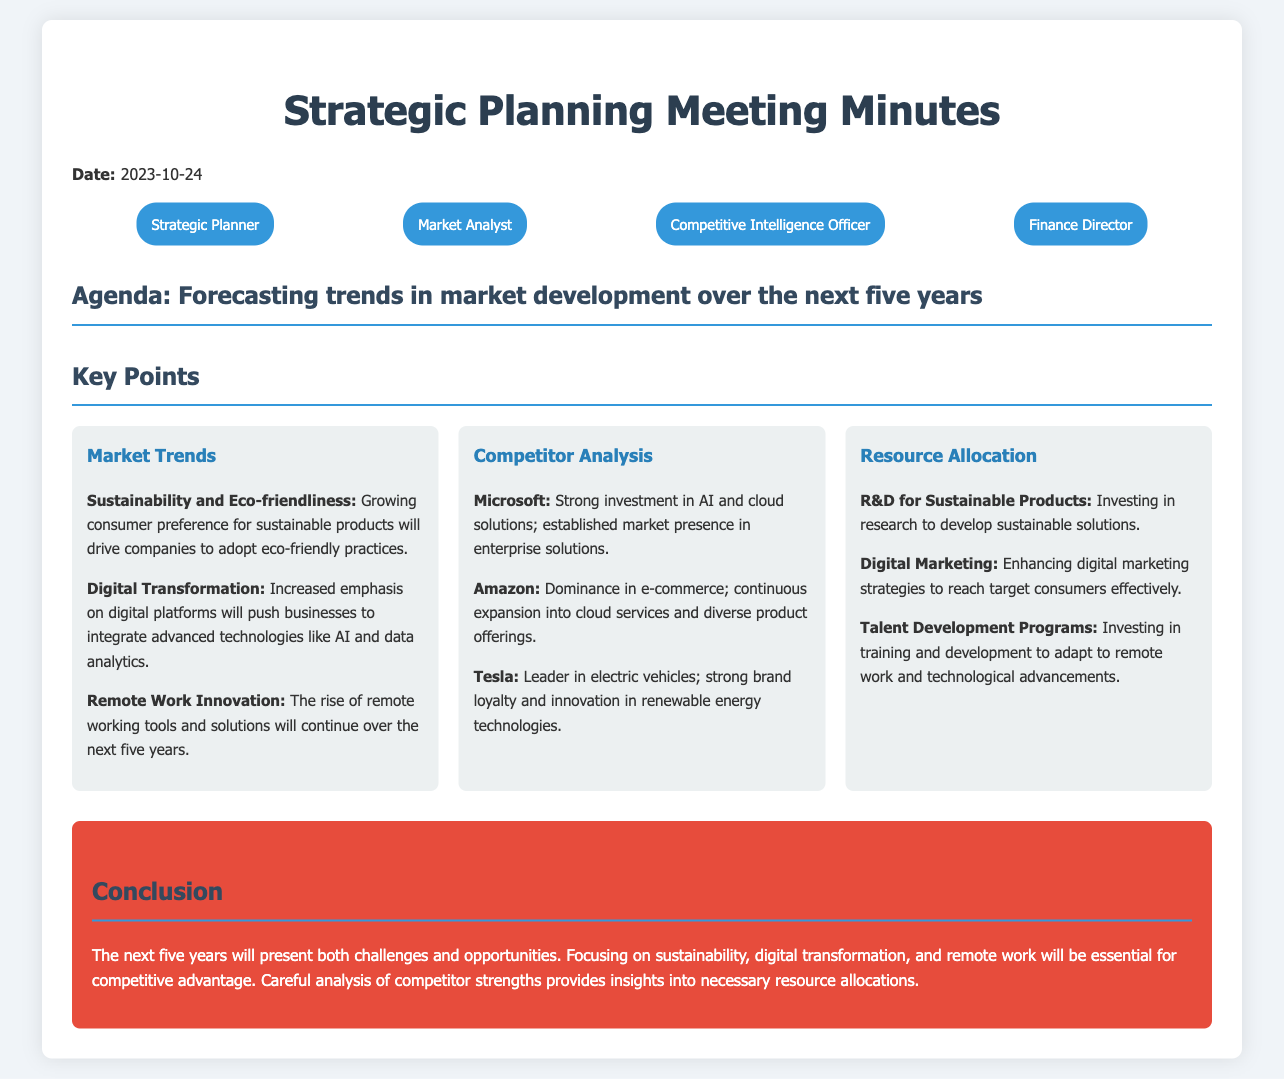What is the date of the meeting? The date of the meeting is stated in the document.
Answer: 2023-10-24 Who is the market analyst? The document lists participants, among whom the market analyst is mentioned.
Answer: Market Analyst What key trend focuses on consumer preferences? The document identifies specific trends, including sustainability preferences.
Answer: Sustainability and Eco-friendliness Which competitor is noted for its dominance in e-commerce? The document highlights major competitors and their strengths.
Answer: Amazon What is one area for resource allocation mentioned? The document outlines several areas for resource allocation.
Answer: R&D for Sustainable Products What technological advancement is emphasized for the next five years? The document mentions trends driving changes in businesses, including technology.
Answer: Digital Transformation How many attendees are listed in the document? The document includes a section specifying the attendees present.
Answer: Four What is a key conclusion from the meeting? The document summarizes the outcome of the discussions with specific emphasis.
Answer: Focus on sustainability, digital transformation, and remote work 